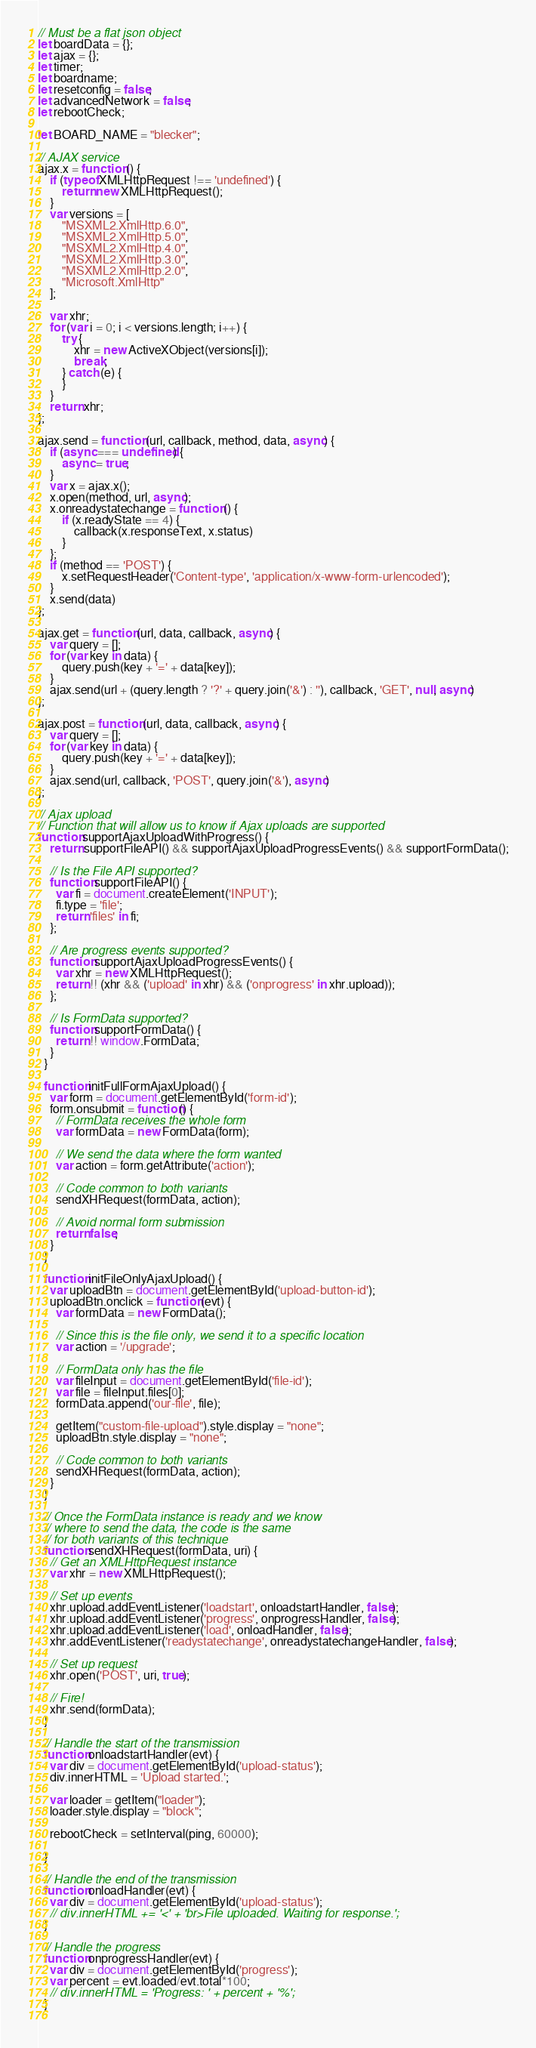<code> <loc_0><loc_0><loc_500><loc_500><_JavaScript_>// Must be a flat json object		
let boardData = {};
let ajax = {};
let timer;
let boardname;
let resetconfig = false;
let advancedNetwork = false;
let rebootCheck;

let BOARD_NAME = "blecker";

// AJAX service
ajax.x = function () {
    if (typeof XMLHttpRequest !== 'undefined') {
        return new XMLHttpRequest();
    }
    var versions = [
        "MSXML2.XmlHttp.6.0",
        "MSXML2.XmlHttp.5.0",
        "MSXML2.XmlHttp.4.0",
        "MSXML2.XmlHttp.3.0",
        "MSXML2.XmlHttp.2.0",
        "Microsoft.XmlHttp"
    ];

    var xhr;
    for (var i = 0; i < versions.length; i++) {
        try {
            xhr = new ActiveXObject(versions[i]);
            break;
        } catch (e) {
        }
    }
    return xhr;
};

ajax.send = function (url, callback, method, data, async) {
    if (async === undefined) {
        async = true;
    }
    var x = ajax.x();
    x.open(method, url, async);
    x.onreadystatechange = function () {
        if (x.readyState == 4) {
            callback(x.responseText, x.status)
        }
    };
    if (method == 'POST') {
        x.setRequestHeader('Content-type', 'application/x-www-form-urlencoded');
    }
    x.send(data)
};

ajax.get = function (url, data, callback, async) {
    var query = [];
    for (var key in data) {
        query.push(key + '=' + data[key]);
    }
    ajax.send(url + (query.length ? '?' + query.join('&') : ''), callback, 'GET', null, async)
};

ajax.post = function (url, data, callback, async) {
    var query = [];
    for (var key in data) {
        query.push(key + '=' + data[key]);
    }
    ajax.send(url, callback, 'POST', query.join('&'), async)
};

// Ajax upload
// Function that will allow us to know if Ajax uploads are supported
function supportAjaxUploadWithProgress() {
    return supportFileAPI() && supportAjaxUploadProgressEvents() && supportFormData();
  
    // Is the File API supported?
    function supportFileAPI() {
      var fi = document.createElement('INPUT');
      fi.type = 'file';
      return 'files' in fi;
    };
  
    // Are progress events supported?
    function supportAjaxUploadProgressEvents() {
      var xhr = new XMLHttpRequest();
      return !! (xhr && ('upload' in xhr) && ('onprogress' in xhr.upload));
    };
  
    // Is FormData supported?
    function supportFormData() {
      return !! window.FormData;
    }
  }
  
  function initFullFormAjaxUpload() {
    var form = document.getElementById('form-id');
    form.onsubmit = function() {
      // FormData receives the whole form
      var formData = new FormData(form);
  
      // We send the data where the form wanted
      var action = form.getAttribute('action');
  
      // Code common to both variants
      sendXHRequest(formData, action);
  
      // Avoid normal form submission
      return false;
    }
  }
  
  function initFileOnlyAjaxUpload() {
    var uploadBtn = document.getElementById('upload-button-id');
    uploadBtn.onclick = function (evt) {
      var formData = new FormData();
  
      // Since this is the file only, we send it to a specific location
      var action = '/upgrade';
  
      // FormData only has the file
      var fileInput = document.getElementById('file-id');
      var file = fileInput.files[0];
      formData.append('our-file', file);

      getItem("custom-file-upload").style.display = "none";
      uploadBtn.style.display = "none";
  
      // Code common to both variants
      sendXHRequest(formData, action);
    }
  }
  
  // Once the FormData instance is ready and we know
  // where to send the data, the code is the same
  // for both variants of this technique
  function sendXHRequest(formData, uri) {
    // Get an XMLHttpRequest instance
    var xhr = new XMLHttpRequest();
  
    // Set up events
    xhr.upload.addEventListener('loadstart', onloadstartHandler, false);
    xhr.upload.addEventListener('progress', onprogressHandler, false);
    xhr.upload.addEventListener('load', onloadHandler, false);
    xhr.addEventListener('readystatechange', onreadystatechangeHandler, false);
  
    // Set up request
    xhr.open('POST', uri, true);
  
    // Fire!
    xhr.send(formData);
  }
  
  // Handle the start of the transmission
  function onloadstartHandler(evt) {
    var div = document.getElementById('upload-status');
    div.innerHTML = 'Upload started.';

    var loader = getItem("loader");
    loader.style.display = "block";

    rebootCheck = setInterval(ping, 60000);

  }
  
  // Handle the end of the transmission
  function onloadHandler(evt) {
    var div = document.getElementById('upload-status');
    // div.innerHTML += '<' + 'br>File uploaded. Waiting for response.';
  }
  
  // Handle the progress
  function onprogressHandler(evt) {
    var div = document.getElementById('progress');
    var percent = evt.loaded/evt.total*100;
    // div.innerHTML = 'Progress: ' + percent + '%';
  }
  </code> 